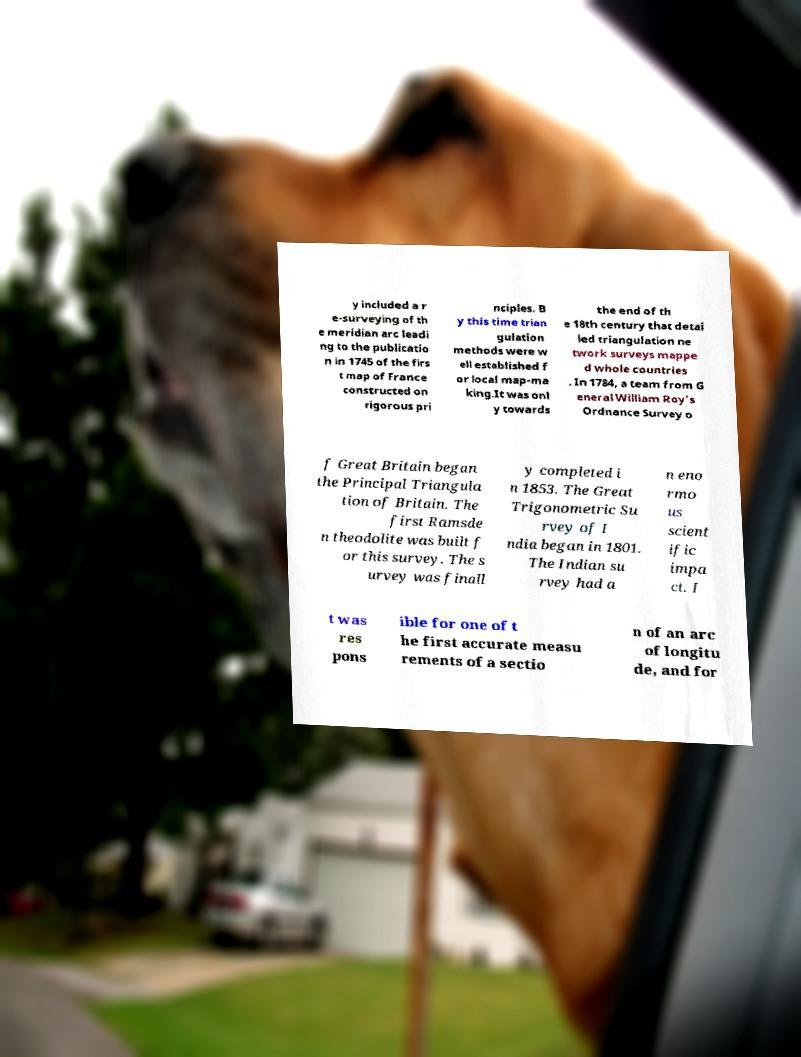Could you extract and type out the text from this image? y included a r e-surveying of th e meridian arc leadi ng to the publicatio n in 1745 of the firs t map of France constructed on rigorous pri nciples. B y this time trian gulation methods were w ell established f or local map-ma king.It was onl y towards the end of th e 18th century that detai led triangulation ne twork surveys mappe d whole countries . In 1784, a team from G eneral William Roy's Ordnance Survey o f Great Britain began the Principal Triangula tion of Britain. The first Ramsde n theodolite was built f or this survey. The s urvey was finall y completed i n 1853. The Great Trigonometric Su rvey of I ndia began in 1801. The Indian su rvey had a n eno rmo us scient ific impa ct. I t was res pons ible for one of t he first accurate measu rements of a sectio n of an arc of longitu de, and for 